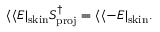Convert formula to latex. <formula><loc_0><loc_0><loc_500><loc_500>\langle \langle E | _ { s k i n } S _ { p r o j } ^ { \dag } = \langle \langle - E | _ { s k i n } .</formula> 